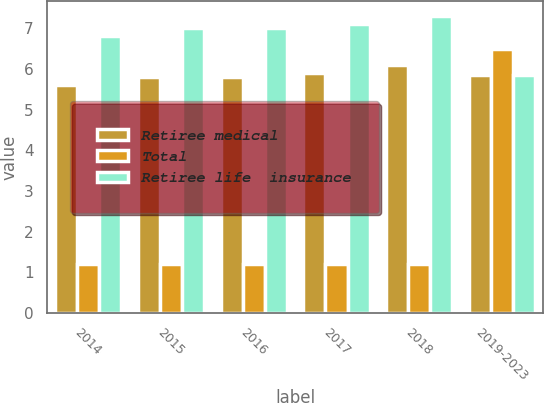Convert chart. <chart><loc_0><loc_0><loc_500><loc_500><stacked_bar_chart><ecel><fcel>2014<fcel>2015<fcel>2016<fcel>2017<fcel>2018<fcel>2019-2023<nl><fcel>Retiree medical<fcel>5.6<fcel>5.8<fcel>5.8<fcel>5.9<fcel>6.1<fcel>5.85<nl><fcel>Total<fcel>1.2<fcel>1.2<fcel>1.2<fcel>1.2<fcel>1.2<fcel>6.5<nl><fcel>Retiree life  insurance<fcel>6.8<fcel>7<fcel>7<fcel>7.1<fcel>7.3<fcel>5.85<nl></chart> 